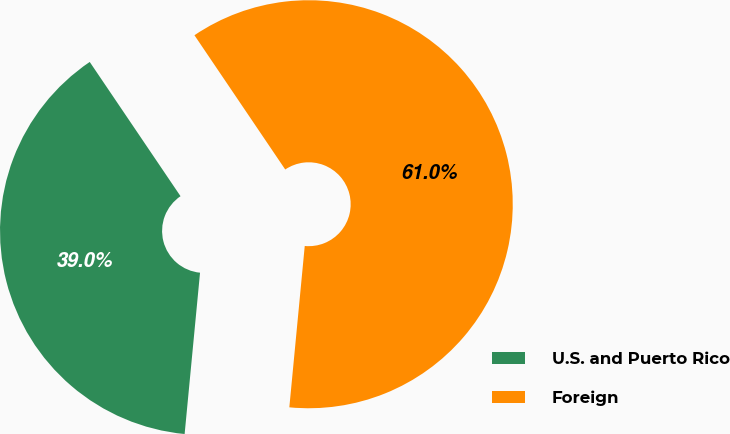<chart> <loc_0><loc_0><loc_500><loc_500><pie_chart><fcel>U.S. and Puerto Rico<fcel>Foreign<nl><fcel>39.02%<fcel>60.98%<nl></chart> 